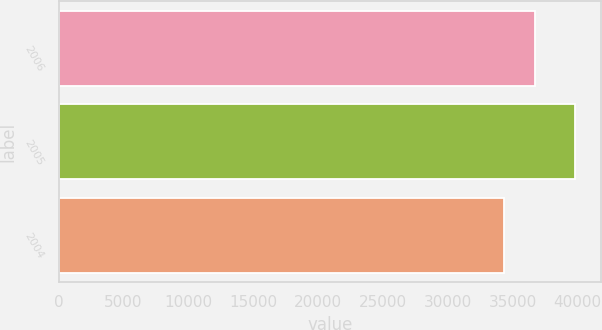Convert chart to OTSL. <chart><loc_0><loc_0><loc_500><loc_500><bar_chart><fcel>2006<fcel>2005<fcel>2004<nl><fcel>36689<fcel>39798<fcel>34299<nl></chart> 